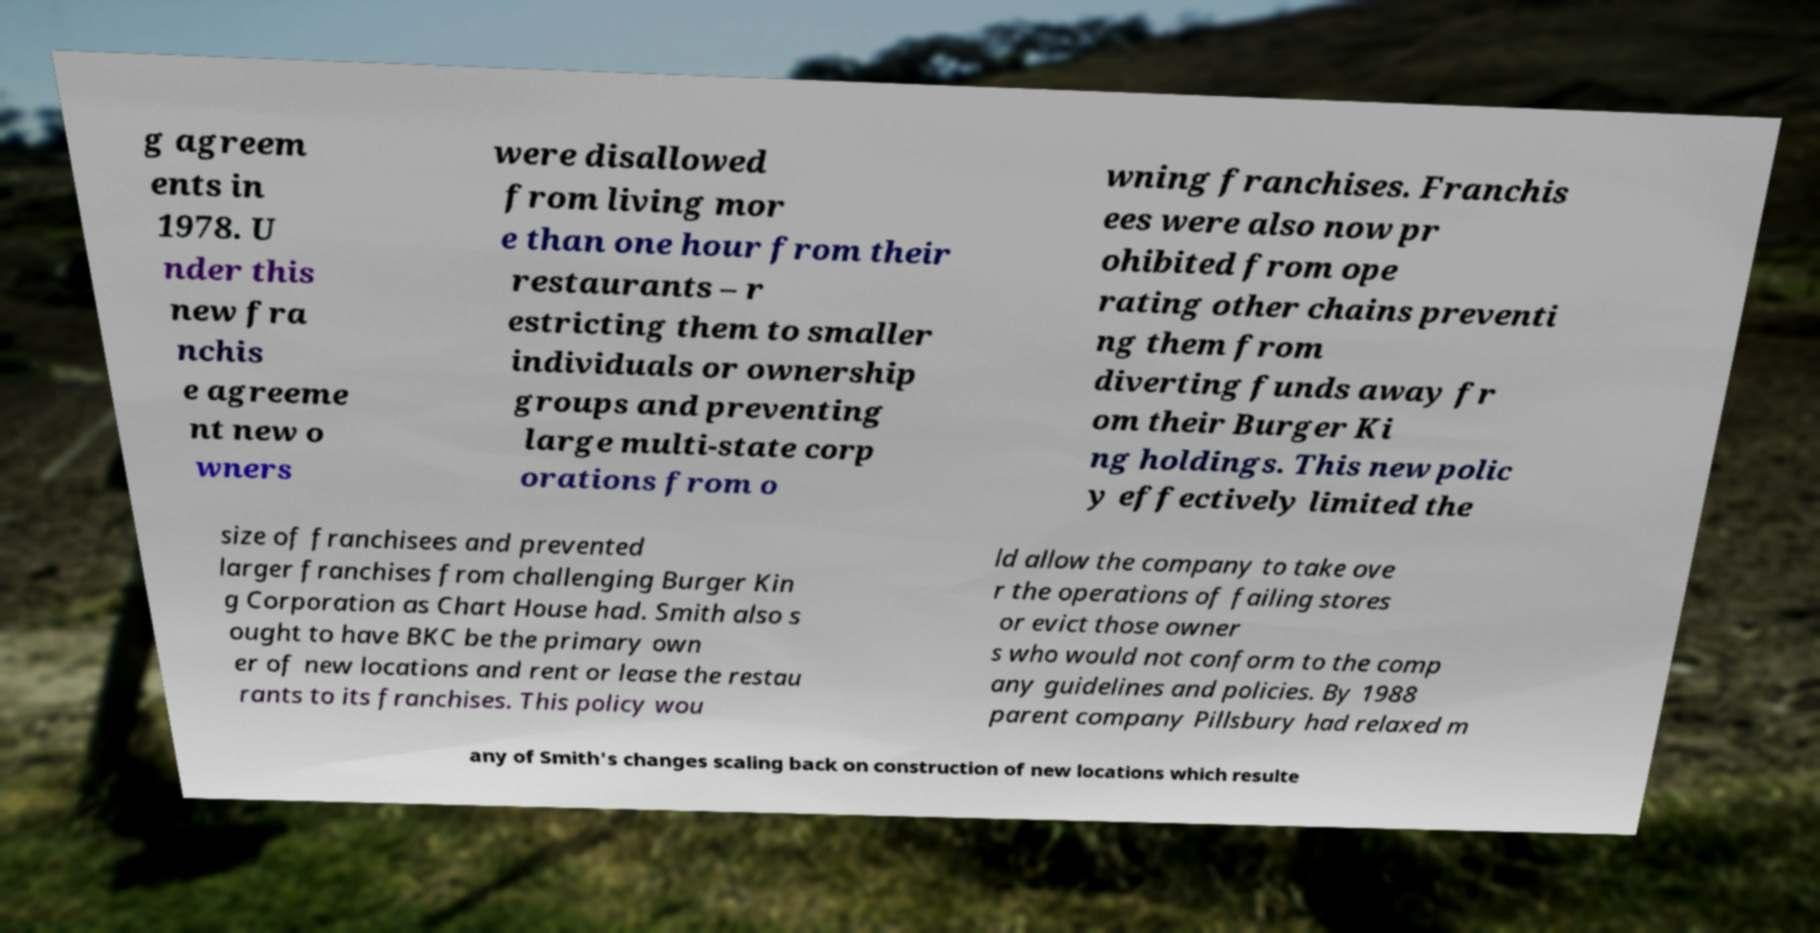Please read and relay the text visible in this image. What does it say? g agreem ents in 1978. U nder this new fra nchis e agreeme nt new o wners were disallowed from living mor e than one hour from their restaurants – r estricting them to smaller individuals or ownership groups and preventing large multi-state corp orations from o wning franchises. Franchis ees were also now pr ohibited from ope rating other chains preventi ng them from diverting funds away fr om their Burger Ki ng holdings. This new polic y effectively limited the size of franchisees and prevented larger franchises from challenging Burger Kin g Corporation as Chart House had. Smith also s ought to have BKC be the primary own er of new locations and rent or lease the restau rants to its franchises. This policy wou ld allow the company to take ove r the operations of failing stores or evict those owner s who would not conform to the comp any guidelines and policies. By 1988 parent company Pillsbury had relaxed m any of Smith's changes scaling back on construction of new locations which resulte 